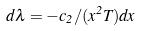Convert formula to latex. <formula><loc_0><loc_0><loc_500><loc_500>d \lambda = - c _ { 2 } / ( x ^ { 2 } T ) d x</formula> 